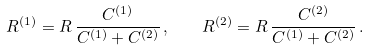<formula> <loc_0><loc_0><loc_500><loc_500>R ^ { ( 1 ) } = R \, \frac { C ^ { ( 1 ) } } { C ^ { ( 1 ) } + C ^ { ( 2 ) } } \, , \quad R ^ { ( 2 ) } = R \, \frac { C ^ { ( 2 ) } } { C ^ { ( 1 ) } + C ^ { ( 2 ) } } \, .</formula> 